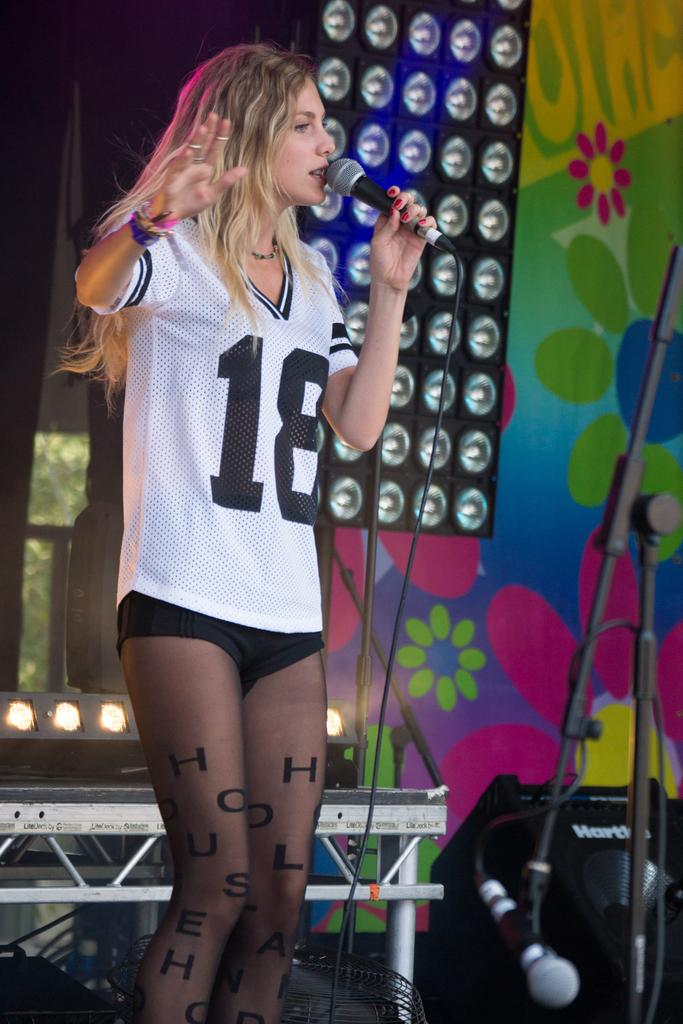<image>
Offer a succinct explanation of the picture presented. A woman wearing a white jersey with the number 18 on it sings into a microphone on stage. 